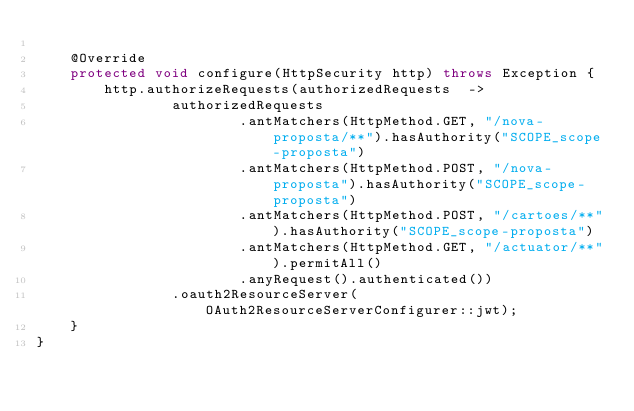<code> <loc_0><loc_0><loc_500><loc_500><_Java_>
    @Override
    protected void configure(HttpSecurity http) throws Exception {
        http.authorizeRequests(authorizedRequests  ->
                authorizedRequests
                        .antMatchers(HttpMethod.GET, "/nova-proposta/**").hasAuthority("SCOPE_scope-proposta")
                        .antMatchers(HttpMethod.POST, "/nova-proposta").hasAuthority("SCOPE_scope-proposta")
                        .antMatchers(HttpMethod.POST, "/cartoes/**").hasAuthority("SCOPE_scope-proposta")
                        .antMatchers(HttpMethod.GET, "/actuator/**").permitAll()
                        .anyRequest().authenticated())
                .oauth2ResourceServer(OAuth2ResourceServerConfigurer::jwt);
    }
}
</code> 